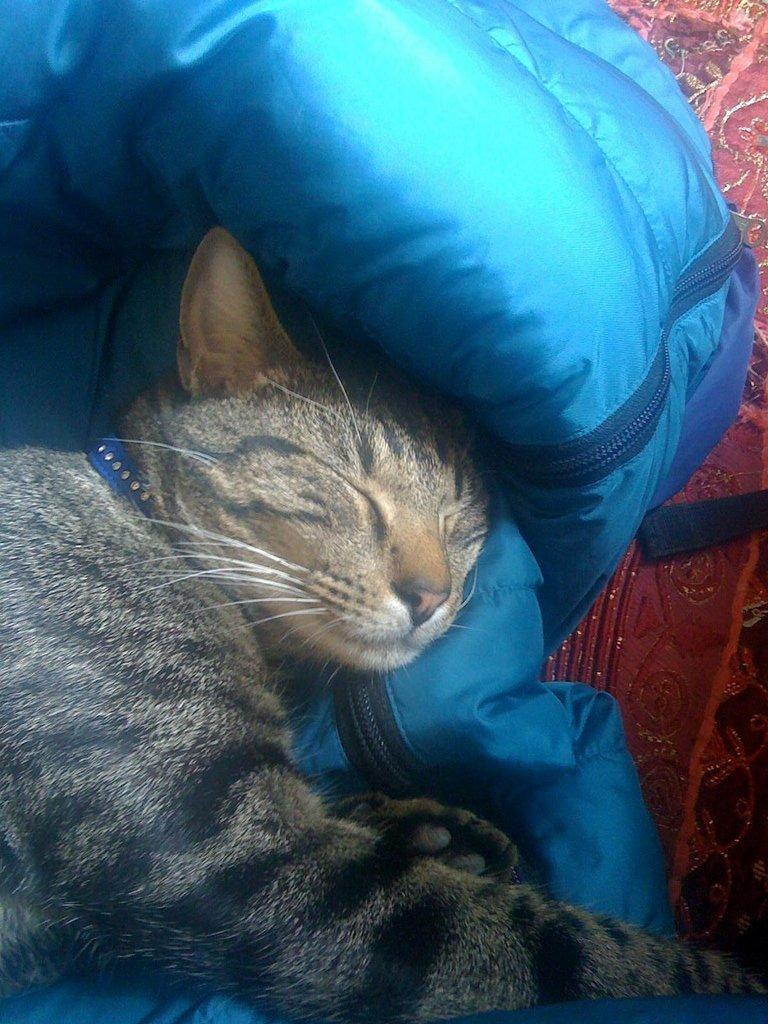What type of animal is present in the image? There is a cat in the image. What color is the object that can be seen in the image? There is a blue colored object in the image. What type of material is visible in the image? There is cloth visible in the image. Can you see a snail crawling on the cat in the image? No, there is no snail present in the image. What type of wool is being used to make the cat's fur in the image? The image does not provide information about the type of wool used for the cat's fur, as it is a photograph of a real cat and not a fabricated image. 